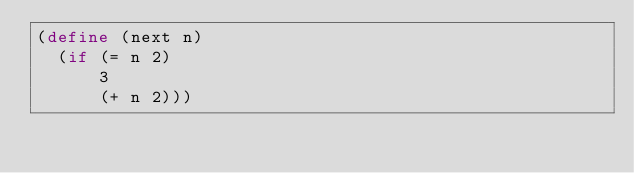Convert code to text. <code><loc_0><loc_0><loc_500><loc_500><_Scheme_>(define (next n)
  (if (= n 2)
      3
      (+ n 2)))</code> 